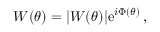<formula> <loc_0><loc_0><loc_500><loc_500>W ( \theta ) = | W ( \theta ) | e ^ { i \Phi ( \theta ) } \, ,</formula> 